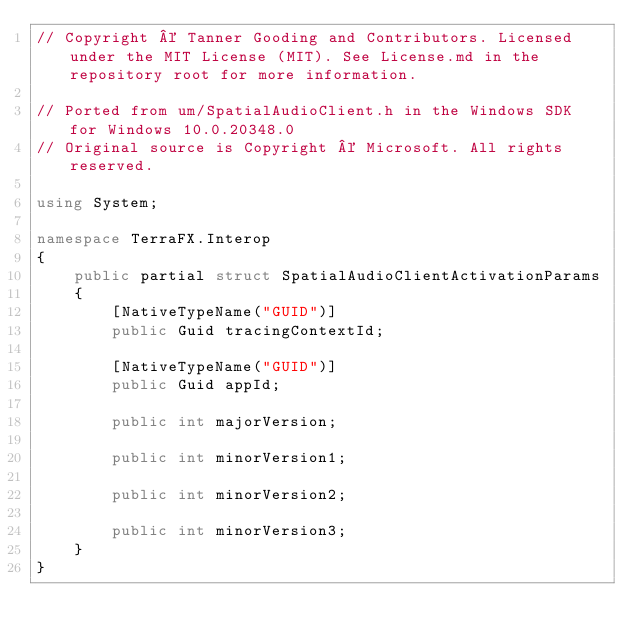Convert code to text. <code><loc_0><loc_0><loc_500><loc_500><_C#_>// Copyright © Tanner Gooding and Contributors. Licensed under the MIT License (MIT). See License.md in the repository root for more information.

// Ported from um/SpatialAudioClient.h in the Windows SDK for Windows 10.0.20348.0
// Original source is Copyright © Microsoft. All rights reserved.

using System;

namespace TerraFX.Interop
{
    public partial struct SpatialAudioClientActivationParams
    {
        [NativeTypeName("GUID")]
        public Guid tracingContextId;

        [NativeTypeName("GUID")]
        public Guid appId;

        public int majorVersion;

        public int minorVersion1;

        public int minorVersion2;

        public int minorVersion3;
    }
}
</code> 